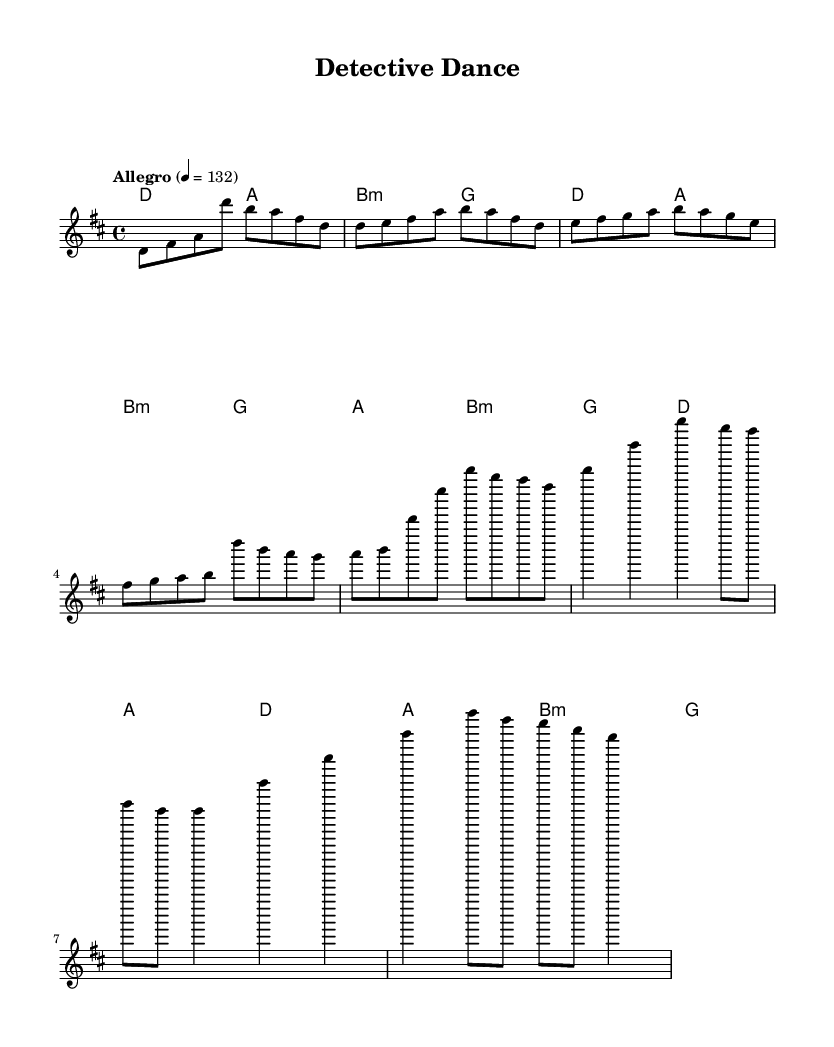What is the key signature of this music? The key can be identified by looking at the key signature at the beginning of the sheet music. It shows two sharps, which indicates that the key is D major.
Answer: D major What is the time signature of this music? The time signature is shown in the beginning of the sheet music, and it is indicated as 4/4. This means there are four beats in each measure and a quarter note receives one beat.
Answer: 4/4 What is the tempo marking of this music? The tempo is indicated at the start of the piece and shows the speed of the music. It states "Allegro" with a metronome marking of 132 beats per minute, suggesting a quick tempo.
Answer: Allegro, 132 How many measures are there in the chorus section? The chorus can be identified by examining the repeated sections of the music. Counting the measures designated for the chorus, there are four distinct measures in this section.
Answer: 4 What are the chord types used in the verse? By analyzing the chords listed in the chord names, the verse consists of D major, A major, B minor, and G major chords. These chords contribute to the overall progression of the verse.
Answer: D, A, B minor, G What is the highest note in the melody? To find the highest note, look at the individual pitches within the melody line. The highest note indicated is a D in the melody, which appears at the beginning of several phrases.
Answer: D What thematic element is represented in this piece? The sheet music is titled "Detective Dance" and has an upbeat tempo, suggesting a theme related to solving mysteries and finding clues, which is often emphasized in K-Pop music.
Answer: Mystery-solving 